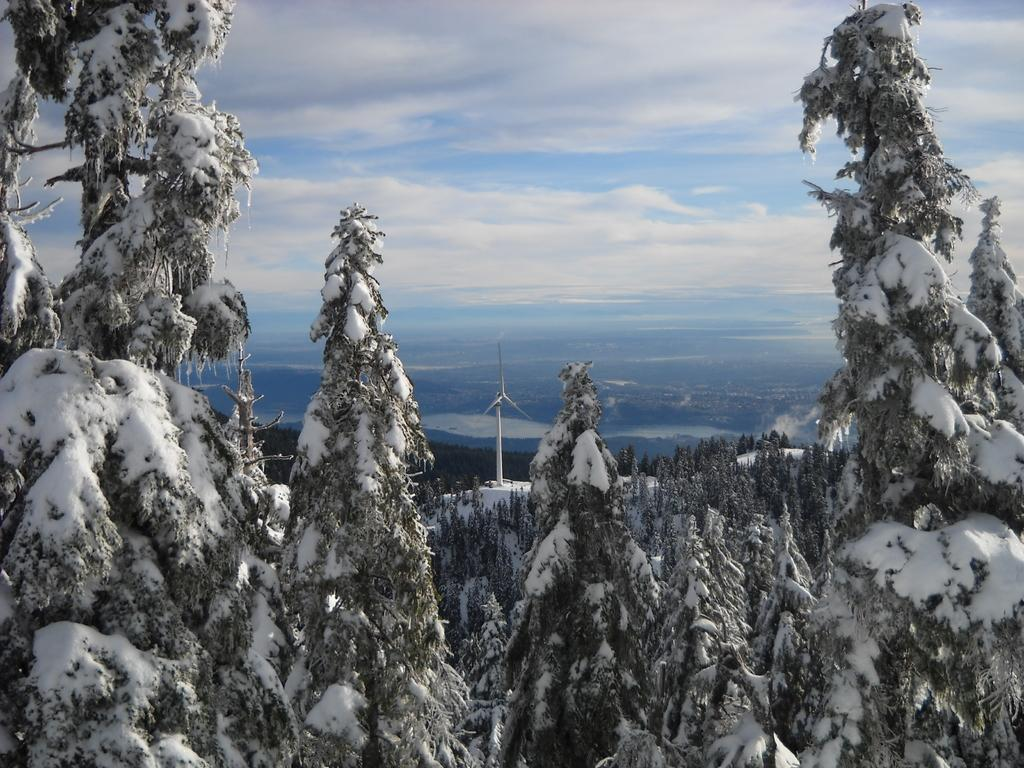What type of vegetation can be seen in the image? There are trees in the image. What is the weather like in the image? There is snow visible in the image, indicating a cold and likely snowy environment. What structure is present in the image? There is a windmill in the image. What is the color and condition of the sky in the image? The sky is blue and cloudy in the image. How many feet are visible in the image? There are no feet visible in the image. Can you see a monkey in the image? There is no monkey present in the image. 